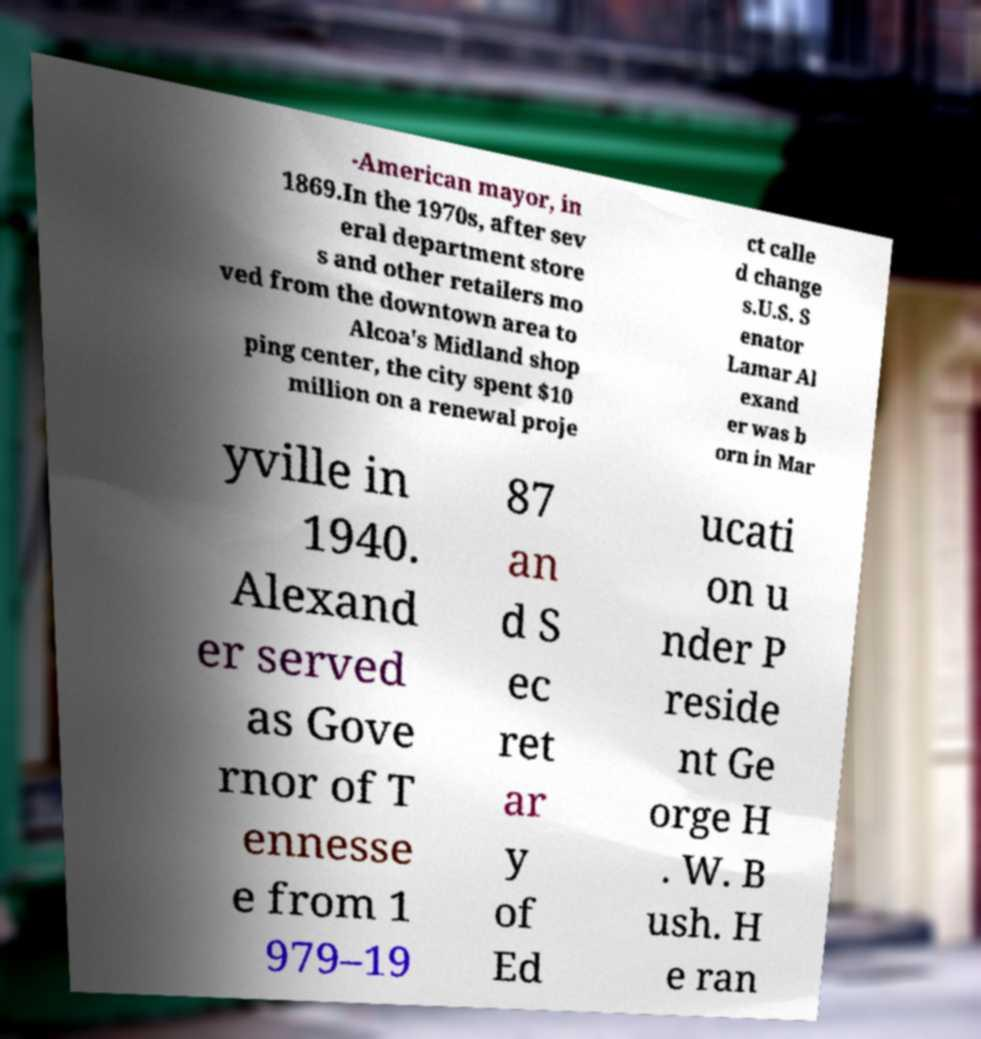I need the written content from this picture converted into text. Can you do that? -American mayor, in 1869.In the 1970s, after sev eral department store s and other retailers mo ved from the downtown area to Alcoa's Midland shop ping center, the city spent $10 million on a renewal proje ct calle d change s.U.S. S enator Lamar Al exand er was b orn in Mar yville in 1940. Alexand er served as Gove rnor of T ennesse e from 1 979–19 87 an d S ec ret ar y of Ed ucati on u nder P reside nt Ge orge H . W. B ush. H e ran 